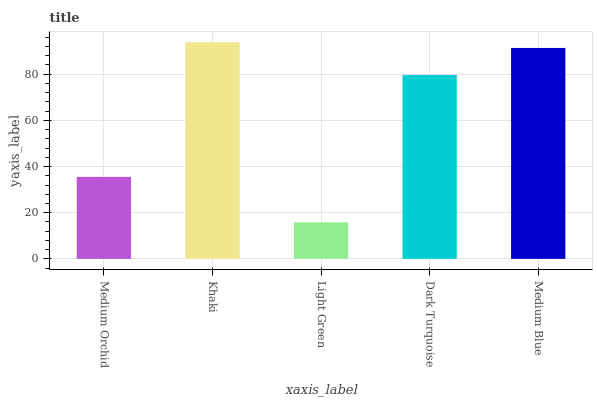Is Khaki the minimum?
Answer yes or no. No. Is Light Green the maximum?
Answer yes or no. No. Is Khaki greater than Light Green?
Answer yes or no. Yes. Is Light Green less than Khaki?
Answer yes or no. Yes. Is Light Green greater than Khaki?
Answer yes or no. No. Is Khaki less than Light Green?
Answer yes or no. No. Is Dark Turquoise the high median?
Answer yes or no. Yes. Is Dark Turquoise the low median?
Answer yes or no. Yes. Is Khaki the high median?
Answer yes or no. No. Is Medium Blue the low median?
Answer yes or no. No. 